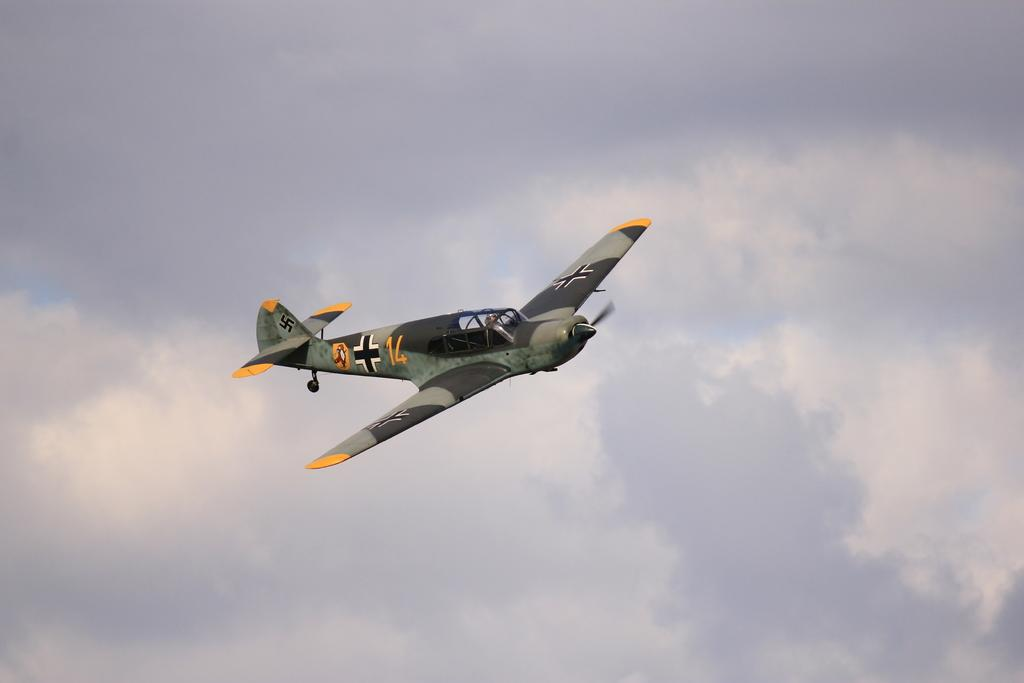What is the main subject of the image? The main subject of the image is an aircraft. What colors can be seen on the aircraft? The aircraft is black, green, and yellow in color. What is the aircraft doing in the image? The aircraft is flying in the air. What can be seen in the background of the image? The sky is visible in the background of the image. Who is the representative of the aircraft in the image? There is no representative of the aircraft in the image, as it is an inanimate object. What attraction can be seen near the aircraft in the image? There is no attraction visible in the image; the image only shows the aircraft flying in the air. 